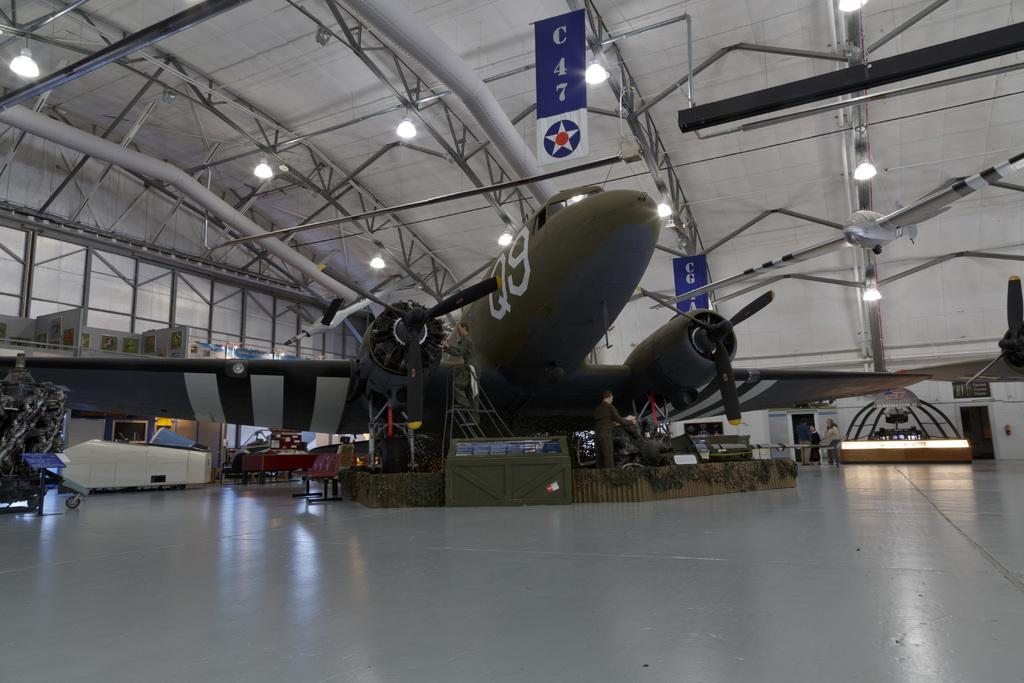<image>
Write a terse but informative summary of the picture. A large green military aircraft is identified with the marker Q9 in thin white letters. 